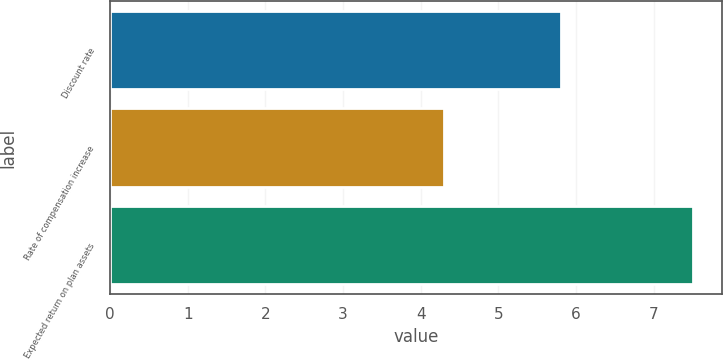Convert chart. <chart><loc_0><loc_0><loc_500><loc_500><bar_chart><fcel>Discount rate<fcel>Rate of compensation increase<fcel>Expected return on plan assets<nl><fcel>5.8<fcel>4.3<fcel>7.5<nl></chart> 